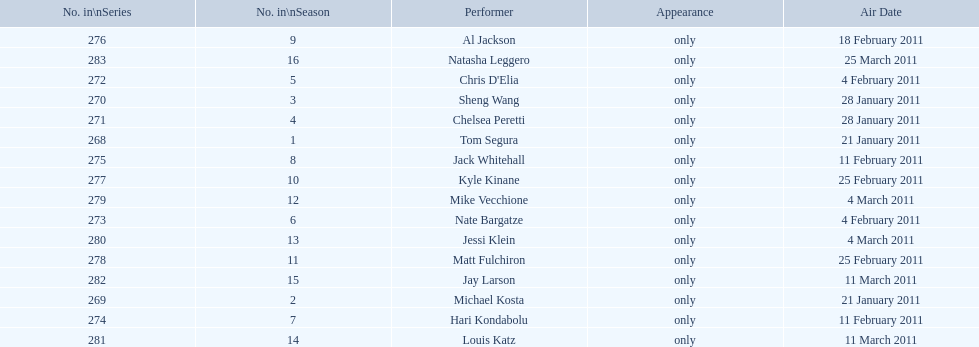How many comedians made their only appearance on comedy central presents in season 15? 16. 